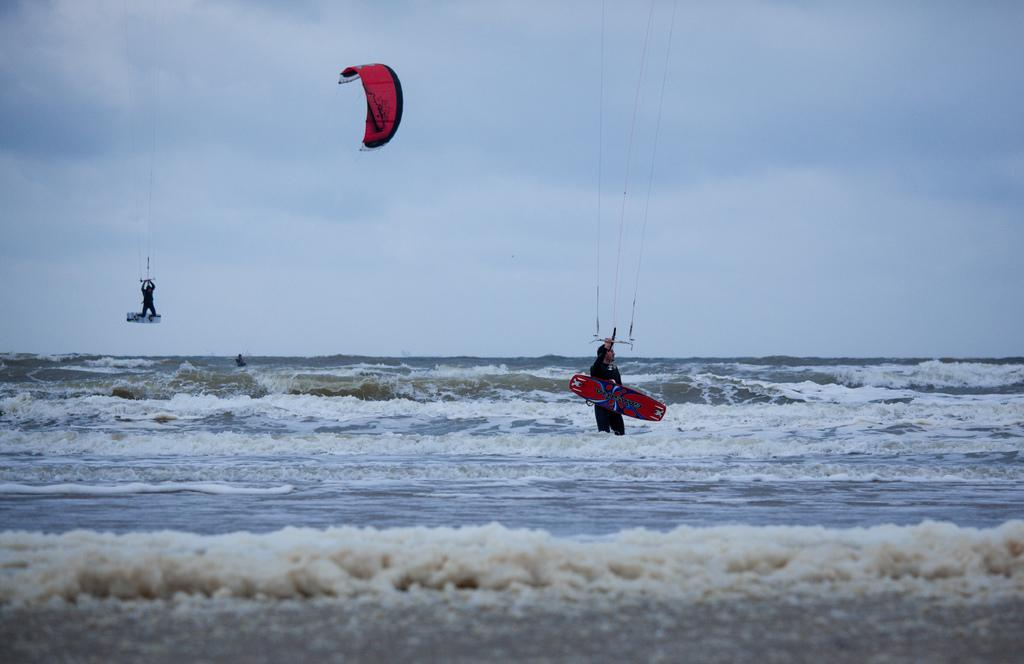What activity is the person in the image engaged in? The person in the image is kite surfing. What object is the man holding in the image? The man is holding a surfboard in the image. Where is the man standing in the image? The man is standing in water in the image. What can be seen in the background of the image? The sky is visible in the background of the image. What is the condition of the sky in the image? Clouds are present in the sky in the image. What type of wire is being used to attack the kite surfer in the image? There is no wire or attack present in the image; the person is kite surfing using a kite. What division is responsible for organizing the kite surfing event in the image? There is no indication of an organized event or division in the image; it simply shows a person kite surfing. 